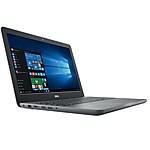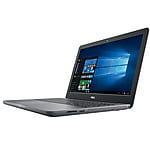The first image is the image on the left, the second image is the image on the right. For the images displayed, is the sentence "The laptops are facing towards the left side of the image." factually correct? Answer yes or no. No. 